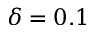Convert formula to latex. <formula><loc_0><loc_0><loc_500><loc_500>\delta = 0 . 1</formula> 